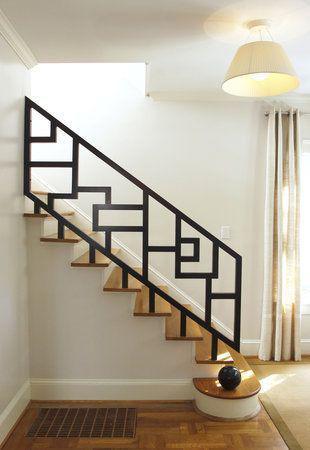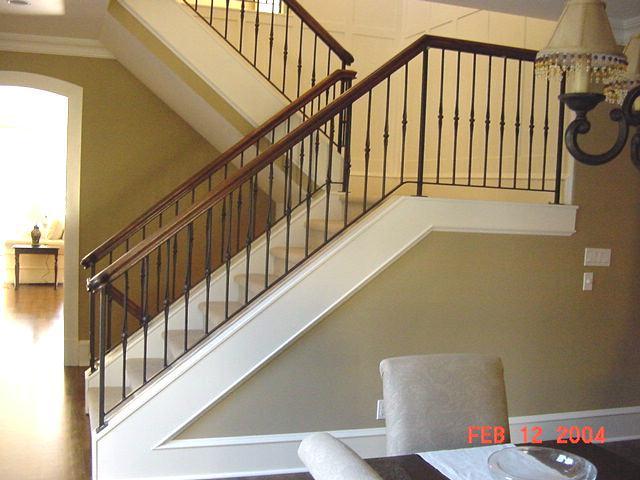The first image is the image on the left, the second image is the image on the right. Examine the images to the left and right. Is the description "One set of stairs heads in just one direction." accurate? Answer yes or no. Yes. The first image is the image on the left, the second image is the image on the right. For the images displayed, is the sentence "An image shows a staircase with upper landing that combines white paint with brown wood steps and features horizontal metal rails instead of vertical ones." factually correct? Answer yes or no. No. 